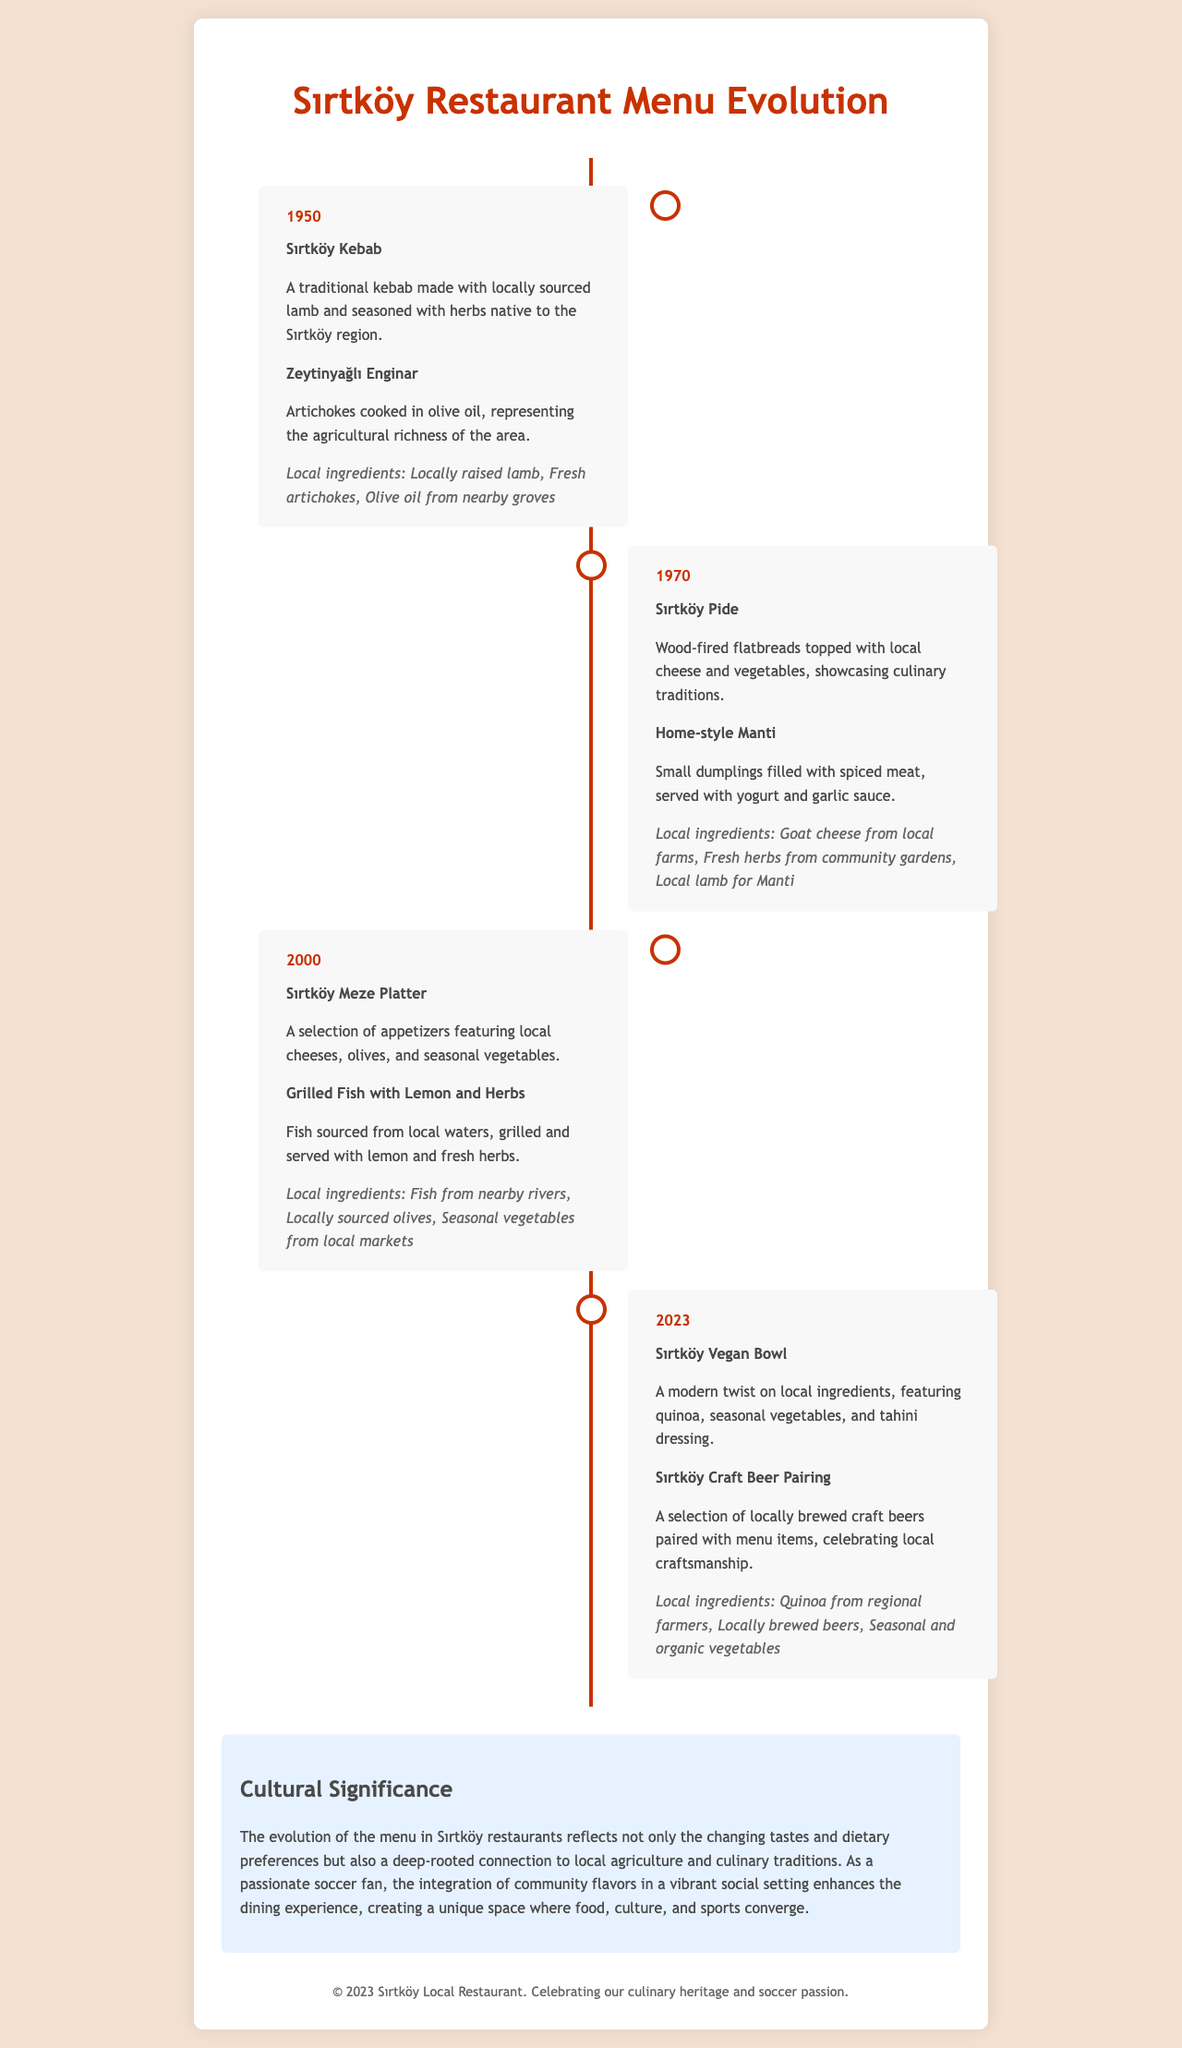What dish was introduced in 1950? The dish introduced in 1950 is Sırtköy Kebab.
Answer: Sırtköy Kebab What local ingredient is used in Zeytinyağlı Enginar? Zeytinyağlı Enginar uses fresh artichokes as a local ingredient.
Answer: Fresh artichokes Which year saw the introduction of Sırtköy Meze Platter? The Sırtköy Meze Platter was introduced in the year 2000.
Answer: 2000 What is a featured ingredient in the 2023 Vegan Bowl? The featured ingredient in the 2023 Vegan Bowl is quinoa.
Answer: Quinoa What type of beer is paired with menu items in 2023? The type of beer that is paired with menu items in 2023 is locally brewed craft beer.
Answer: Locally brewed craft beer What cultural aspect does the 2023 menu evolution highlight? The 2023 menu evolution highlights the deep-rooted connection to local agriculture and culinary traditions.
Answer: Local agriculture and culinary traditions How many dishes are highlighted from the year 1970? There are two dishes highlighted from the year 1970.
Answer: Two dishes What culinary characteristic is emphasized in Sırtköy Pide? The culinary characteristic emphasized in Sırtköy Pide is wood-fired cooking.
Answer: Wood-fired cooking 